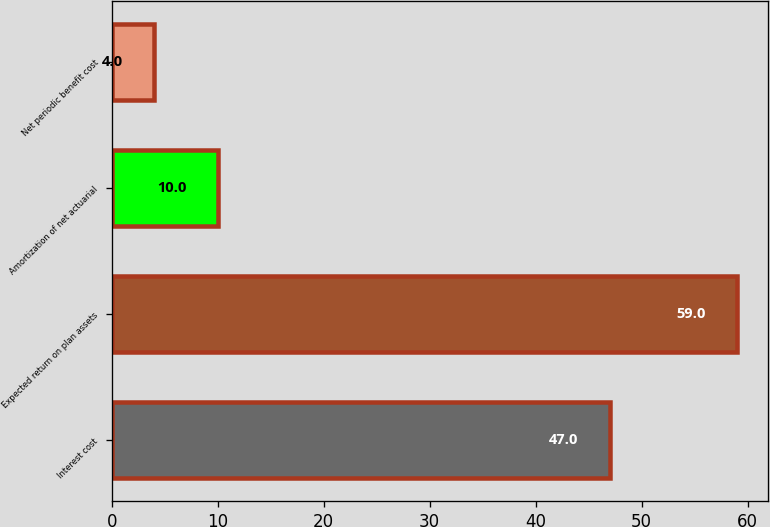<chart> <loc_0><loc_0><loc_500><loc_500><bar_chart><fcel>Interest cost<fcel>Expected return on plan assets<fcel>Amortization of net actuarial<fcel>Net periodic benefit cost<nl><fcel>47<fcel>59<fcel>10<fcel>4<nl></chart> 